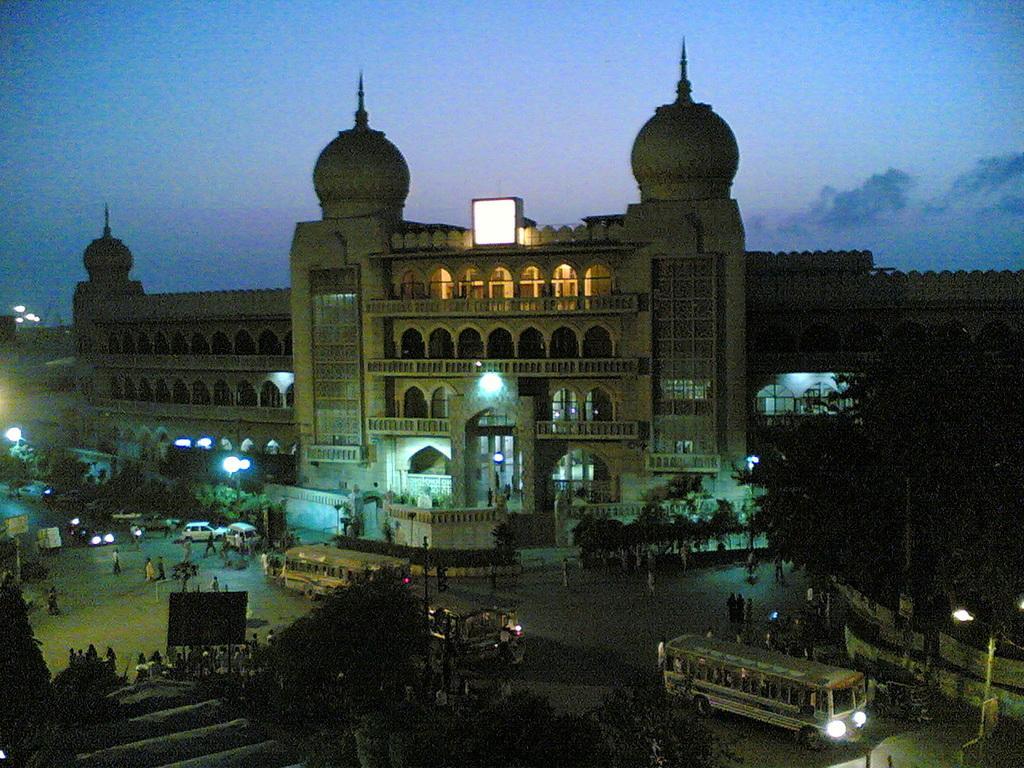Describe this image in one or two sentences. This is an aerial view of an image where we can see vehicles moving on the road and people walking on the road, I can see trees, light poles, traffic signal poles a building lights and the dark sky with clouds in the background. 